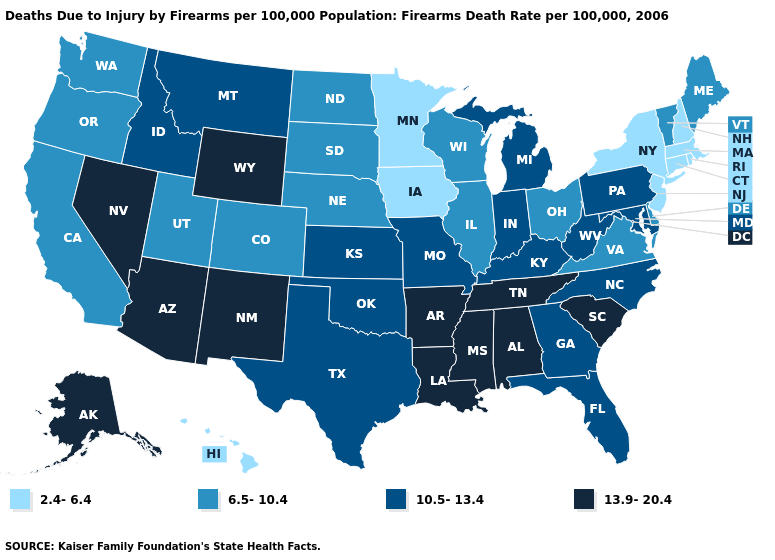Which states hav the highest value in the West?
Short answer required. Alaska, Arizona, Nevada, New Mexico, Wyoming. Name the states that have a value in the range 2.4-6.4?
Answer briefly. Connecticut, Hawaii, Iowa, Massachusetts, Minnesota, New Hampshire, New Jersey, New York, Rhode Island. What is the value of Georgia?
Be succinct. 10.5-13.4. What is the value of Georgia?
Be succinct. 10.5-13.4. Is the legend a continuous bar?
Answer briefly. No. What is the value of West Virginia?
Keep it brief. 10.5-13.4. Among the states that border Delaware , which have the highest value?
Give a very brief answer. Maryland, Pennsylvania. What is the value of West Virginia?
Be succinct. 10.5-13.4. Does the map have missing data?
Short answer required. No. Name the states that have a value in the range 10.5-13.4?
Write a very short answer. Florida, Georgia, Idaho, Indiana, Kansas, Kentucky, Maryland, Michigan, Missouri, Montana, North Carolina, Oklahoma, Pennsylvania, Texas, West Virginia. Which states hav the highest value in the West?
Be succinct. Alaska, Arizona, Nevada, New Mexico, Wyoming. Does the map have missing data?
Short answer required. No. What is the value of Indiana?
Concise answer only. 10.5-13.4. Which states have the highest value in the USA?
Keep it brief. Alabama, Alaska, Arizona, Arkansas, Louisiana, Mississippi, Nevada, New Mexico, South Carolina, Tennessee, Wyoming. What is the highest value in states that border Wisconsin?
Give a very brief answer. 10.5-13.4. 